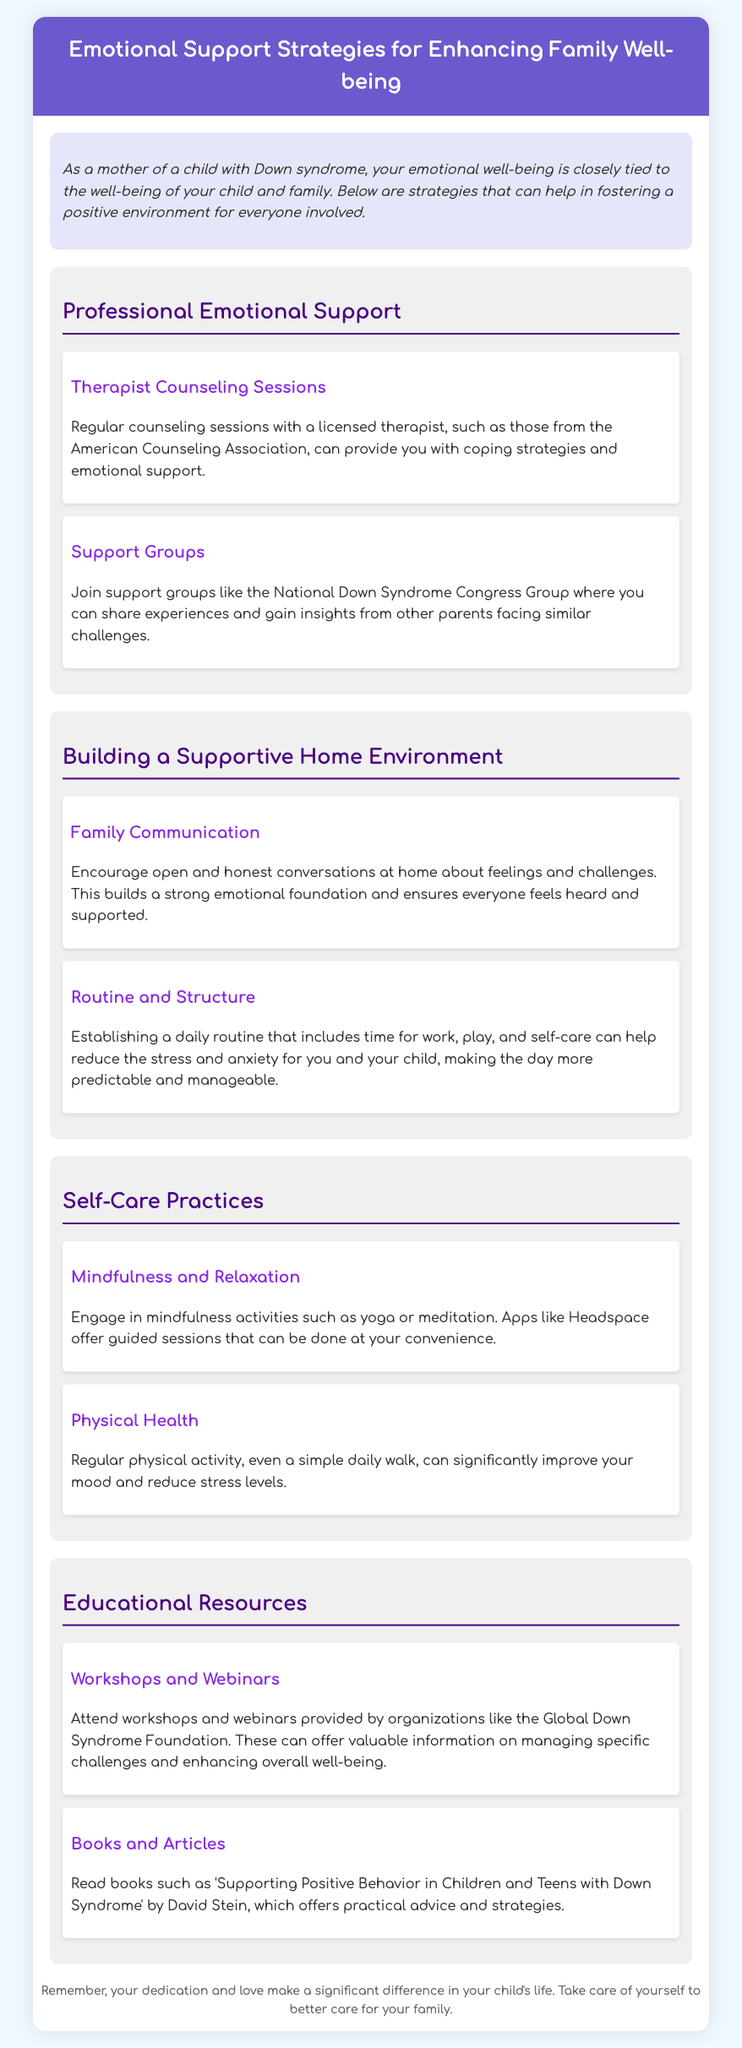What is the title of the document? The title of the document is stated in the header section of the document.
Answer: Emotional Support Strategies for Enhancing Family Well-being What is recommended for regular emotional support? The document suggests specific types of professional support that are available for emotional well-being.
Answer: Therapist Counseling Sessions Which organization is associated with support groups? The document mentions a specific organization that provides support groups for parents of children with Down syndrome.
Answer: National Down Syndrome Congress Group What self-care activity is suggested for relaxation? The document provides recommendations for self-care practices and includes examples of mindfulness activities.
Answer: Yoga What type of resources are suggested for educational purposes? Various educational resources are mentioned in the document aimed at parents seeking further information.
Answer: Workshops and Webinars How does the document suggest building a strong emotional foundation? The document outlines methods for enhancing family well-being, emphasizing the importance of communication within the family.
Answer: Family Communication What book is recommended in the document? The document lists specific literature that offers guidance on supporting children and teens with Down syndrome.
Answer: Supporting Positive Behavior in Children and Teens with Down Syndrome How can regular physical activity impact mood? The document discusses the benefits of physical activity on emotional health without giving specific statistics.
Answer: Significantly improve mood What is a suggested app for mindfulness activities? The document names a specific app that offers guided mindfulness sessions that can be used conveniently.
Answer: Headspace 